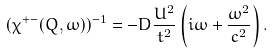<formula> <loc_0><loc_0><loc_500><loc_500>( \chi ^ { + - } ( Q , \omega ) ) ^ { - 1 } = - D \frac { U ^ { 2 } } { t ^ { 2 } } \left ( i \omega + \frac { \omega ^ { 2 } } { c ^ { 2 } } \right ) .</formula> 